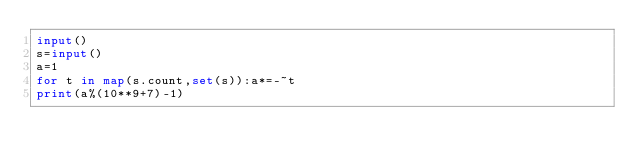<code> <loc_0><loc_0><loc_500><loc_500><_Python_>input()
s=input()
a=1
for t in map(s.count,set(s)):a*=-~t
print(a%(10**9+7)-1)</code> 